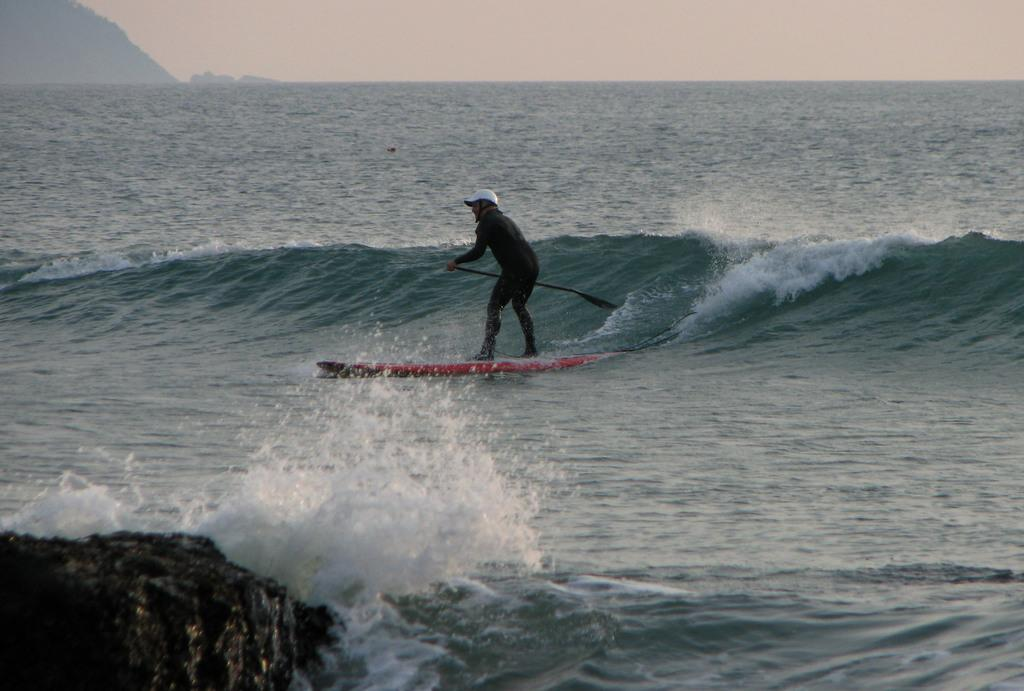What is the main subject of the image? There is a person in the image. What is the person doing in the image? The person is surfing. What can be seen in the background of the image? There are mountains and the sky visible in the image. Can you describe the object the person is holding? The person is holding an object, but the specific details of the object are not clear from the image. What is located in the bottom left corner of the image? There is an object in the bottom left corner of the image. How many ants can be seen crawling on the person's elbow in the image? There are no ants visible in the image, and the person's elbow is not shown. 